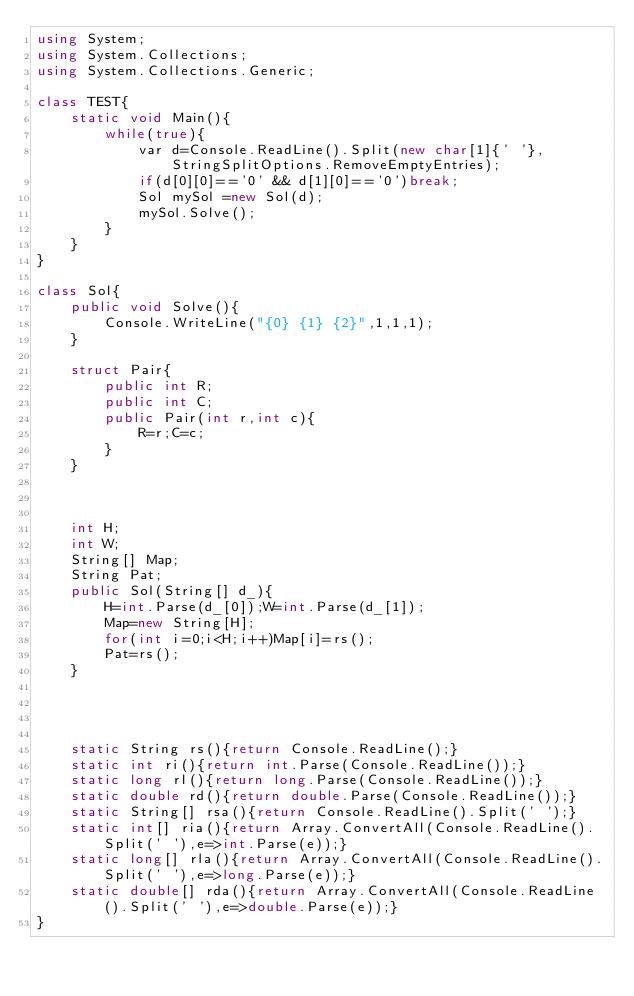Convert code to text. <code><loc_0><loc_0><loc_500><loc_500><_C#_>using System;
using System.Collections;
using System.Collections.Generic;
 
class TEST{
	static void Main(){
		while(true){
			var d=Console.ReadLine().Split(new char[1]{' '}, StringSplitOptions.RemoveEmptyEntries);
			if(d[0][0]=='0' && d[1][0]=='0')break;
			Sol mySol =new Sol(d);
			mySol.Solve();
		}
	}
}

class Sol{
	public void Solve(){
		Console.WriteLine("{0} {1} {2}",1,1,1);
	}
	
	struct Pair{
		public int R;
		public int C;
		public Pair(int r,int c){
			R=r;C=c;
		}
	}
	
	
	
	int H;
	int W;
	String[] Map;
	String Pat;
	public Sol(String[] d_){
		H=int.Parse(d_[0]);W=int.Parse(d_[1]);
		Map=new String[H];
		for(int i=0;i<H;i++)Map[i]=rs();
		Pat=rs();
	}




	static String rs(){return Console.ReadLine();}
	static int ri(){return int.Parse(Console.ReadLine());}
	static long rl(){return long.Parse(Console.ReadLine());}
	static double rd(){return double.Parse(Console.ReadLine());}
	static String[] rsa(){return Console.ReadLine().Split(' ');}
	static int[] ria(){return Array.ConvertAll(Console.ReadLine().Split(' '),e=>int.Parse(e));}
	static long[] rla(){return Array.ConvertAll(Console.ReadLine().Split(' '),e=>long.Parse(e));}
	static double[] rda(){return Array.ConvertAll(Console.ReadLine().Split(' '),e=>double.Parse(e));}
}</code> 